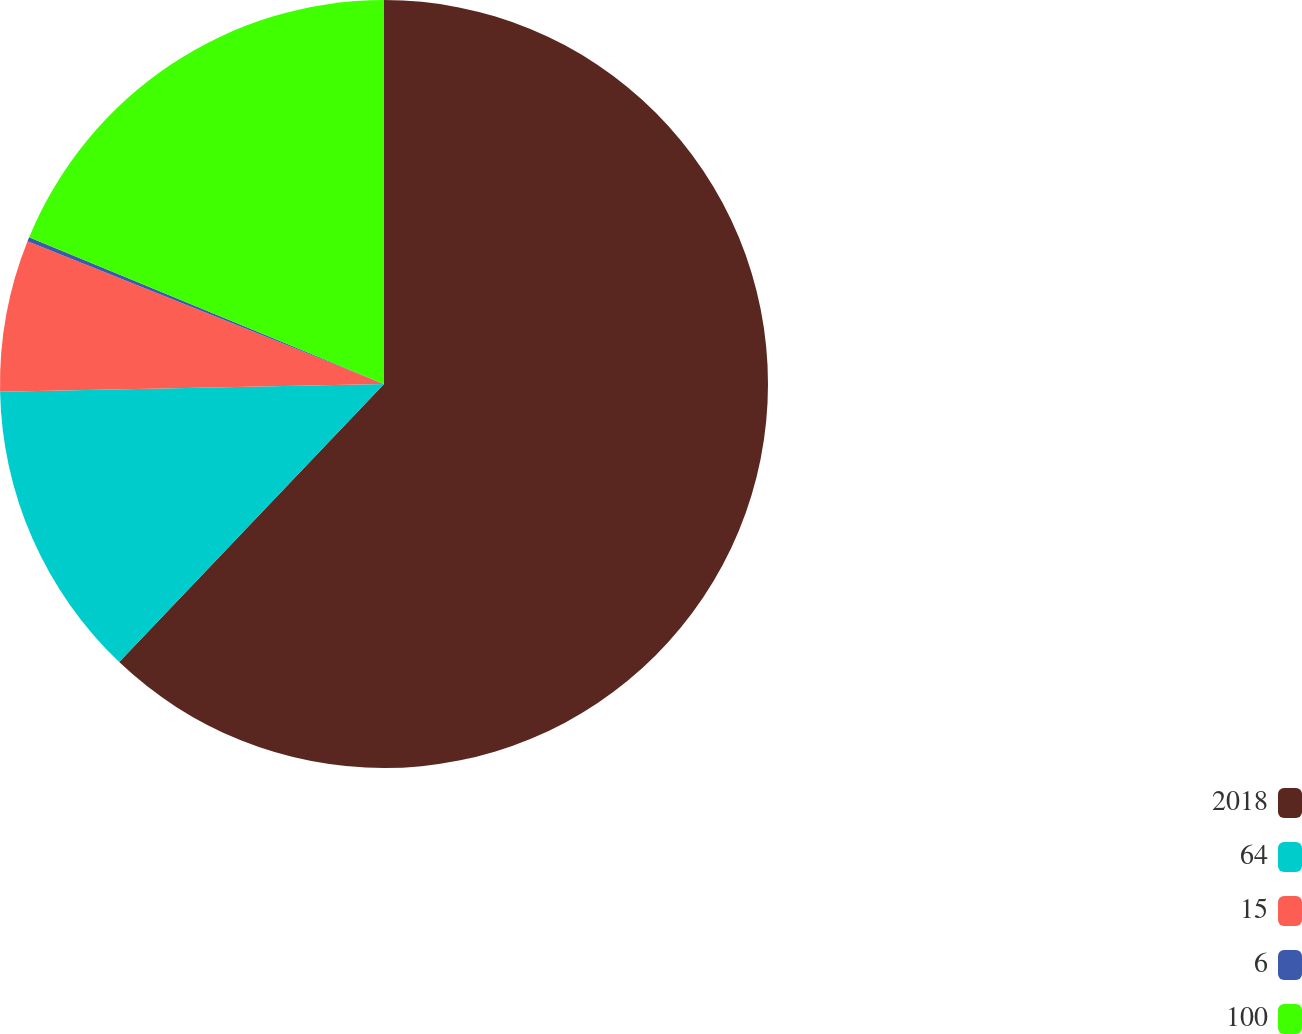<chart> <loc_0><loc_0><loc_500><loc_500><pie_chart><fcel>2018<fcel>64<fcel>15<fcel>6<fcel>100<nl><fcel>62.11%<fcel>12.57%<fcel>6.38%<fcel>0.18%<fcel>18.76%<nl></chart> 